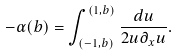<formula> <loc_0><loc_0><loc_500><loc_500>- \alpha ( b ) = \int _ { ( - 1 , b ) } ^ { ( 1 , b ) } \frac { d u } { 2 u \partial _ { x } u } .</formula> 